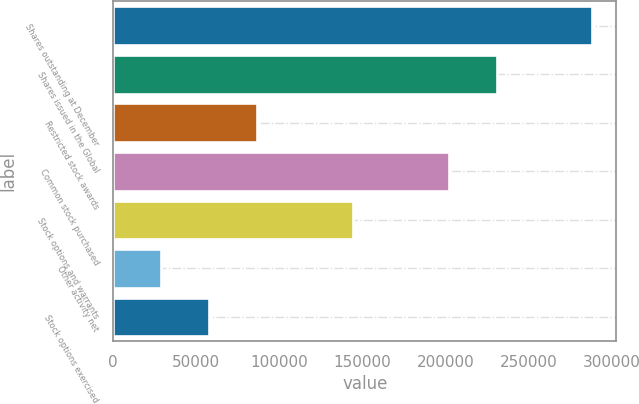Convert chart. <chart><loc_0><loc_0><loc_500><loc_500><bar_chart><fcel>Shares outstanding at December<fcel>Shares issued in the Global<fcel>Restricted stock awards<fcel>Common stock purchased<fcel>Stock options and warrants<fcel>Other activity net<fcel>Stock options exercised<nl><fcel>288464<fcel>230790<fcel>86603.6<fcel>201952<fcel>144278<fcel>28929.2<fcel>57766.4<nl></chart> 